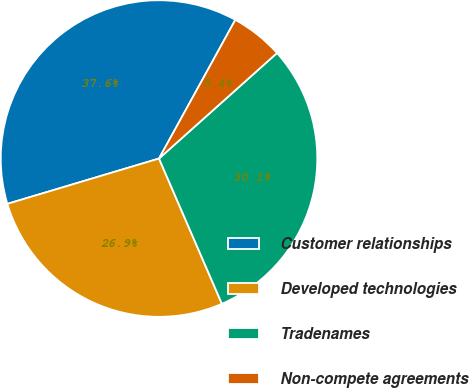Convert chart. <chart><loc_0><loc_0><loc_500><loc_500><pie_chart><fcel>Customer relationships<fcel>Developed technologies<fcel>Tradenames<fcel>Non-compete agreements<nl><fcel>37.63%<fcel>26.88%<fcel>30.11%<fcel>5.38%<nl></chart> 